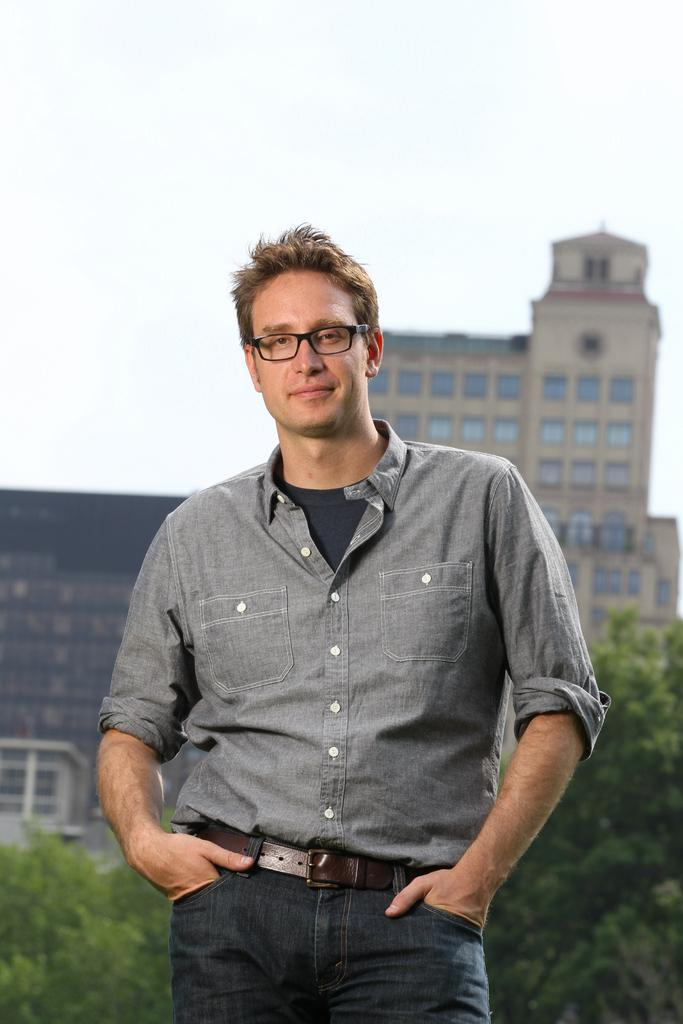Who or what is the main subject in the image? There is a person in the image. Can you describe the person's attire? The person is wearing a grey and black color dress. What accessory is the person wearing? The person is wearing specs. What can be seen in the background of the image? There are many trees, buildings, and the sky visible in the background of the image. Are there any branches covered in wax in the image? There is no mention of branches or wax in the image; it features a person wearing a grey and black dress, specs, and a background with trees, buildings, and the sky. 